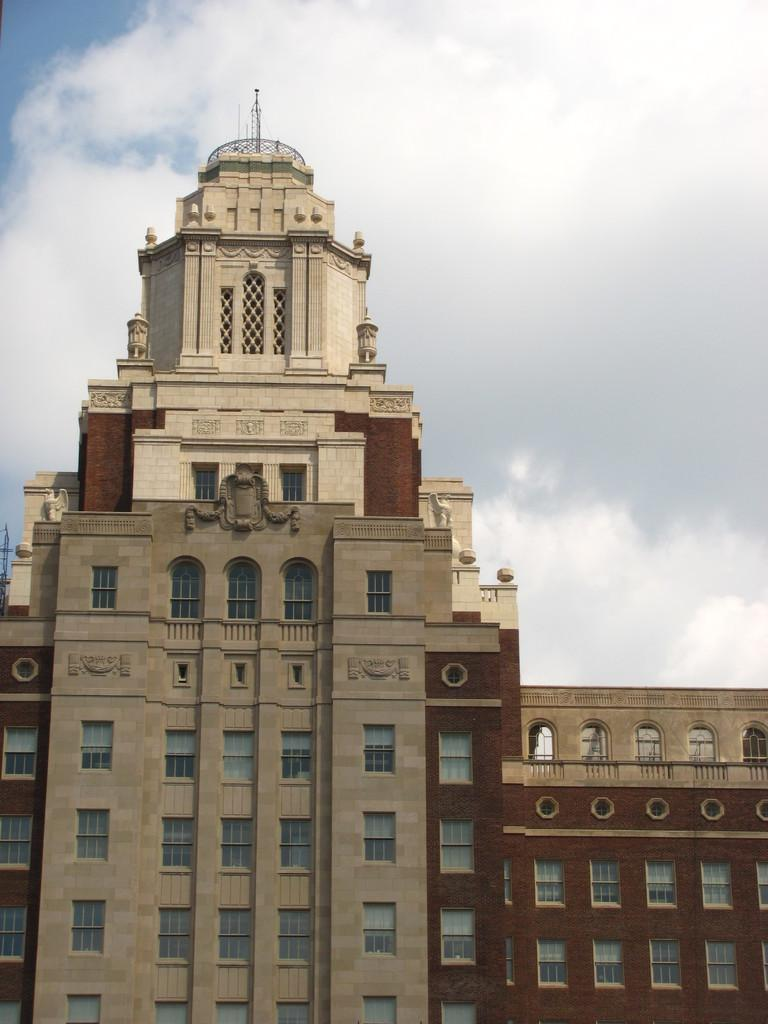What is the main subject of the image? The main subject of the image is a huge building. Can you describe the building's appearance? The building has a lot of windows and carvings on its walls. How many passengers are visible inside the building in the image? There are no passengers visible inside the building in the image, as it is an exterior view of the building. 